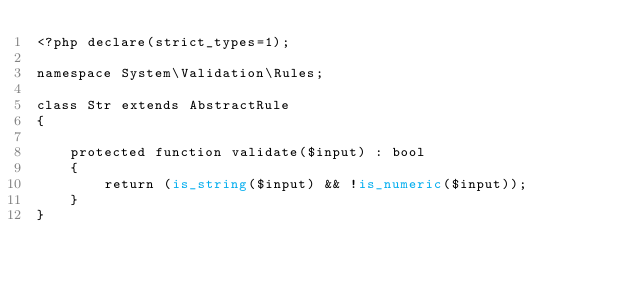<code> <loc_0><loc_0><loc_500><loc_500><_PHP_><?php declare(strict_types=1);

namespace System\Validation\Rules;

class Str extends AbstractRule
{

    protected function validate($input) : bool
    {
        return (is_string($input) && !is_numeric($input));
    }
}
</code> 